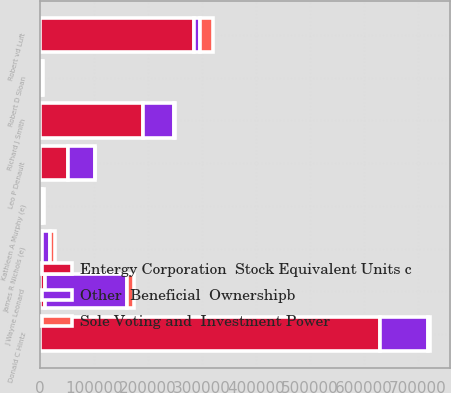<chart> <loc_0><loc_0><loc_500><loc_500><stacked_bar_chart><ecel><fcel>Leo P Denault<fcel>Donald C Hintz<fcel>J Wayne Leonard<fcel>Robert vd Luft<fcel>Kathleen A Murphy (e)<fcel>James R Nichols (e)<fcel>Robert D Sloan<fcel>Richard J Smith<nl><fcel>Sole Voting and  Investment Power<fcel>951<fcel>4963<fcel>13433<fcel>24472<fcel>2700<fcel>8910<fcel>309<fcel>1658<nl><fcel>Entergy Corporation  Stock Equivalent Units c<fcel>52423<fcel>630000<fcel>9600<fcel>285667<fcel>1000<fcel>3684<fcel>4033<fcel>190538<nl><fcel>Other  Beneficial  Ownershipb<fcel>48924<fcel>87605<fcel>150731<fcel>9600<fcel>3200<fcel>14400<fcel>217<fcel>56875<nl></chart> 